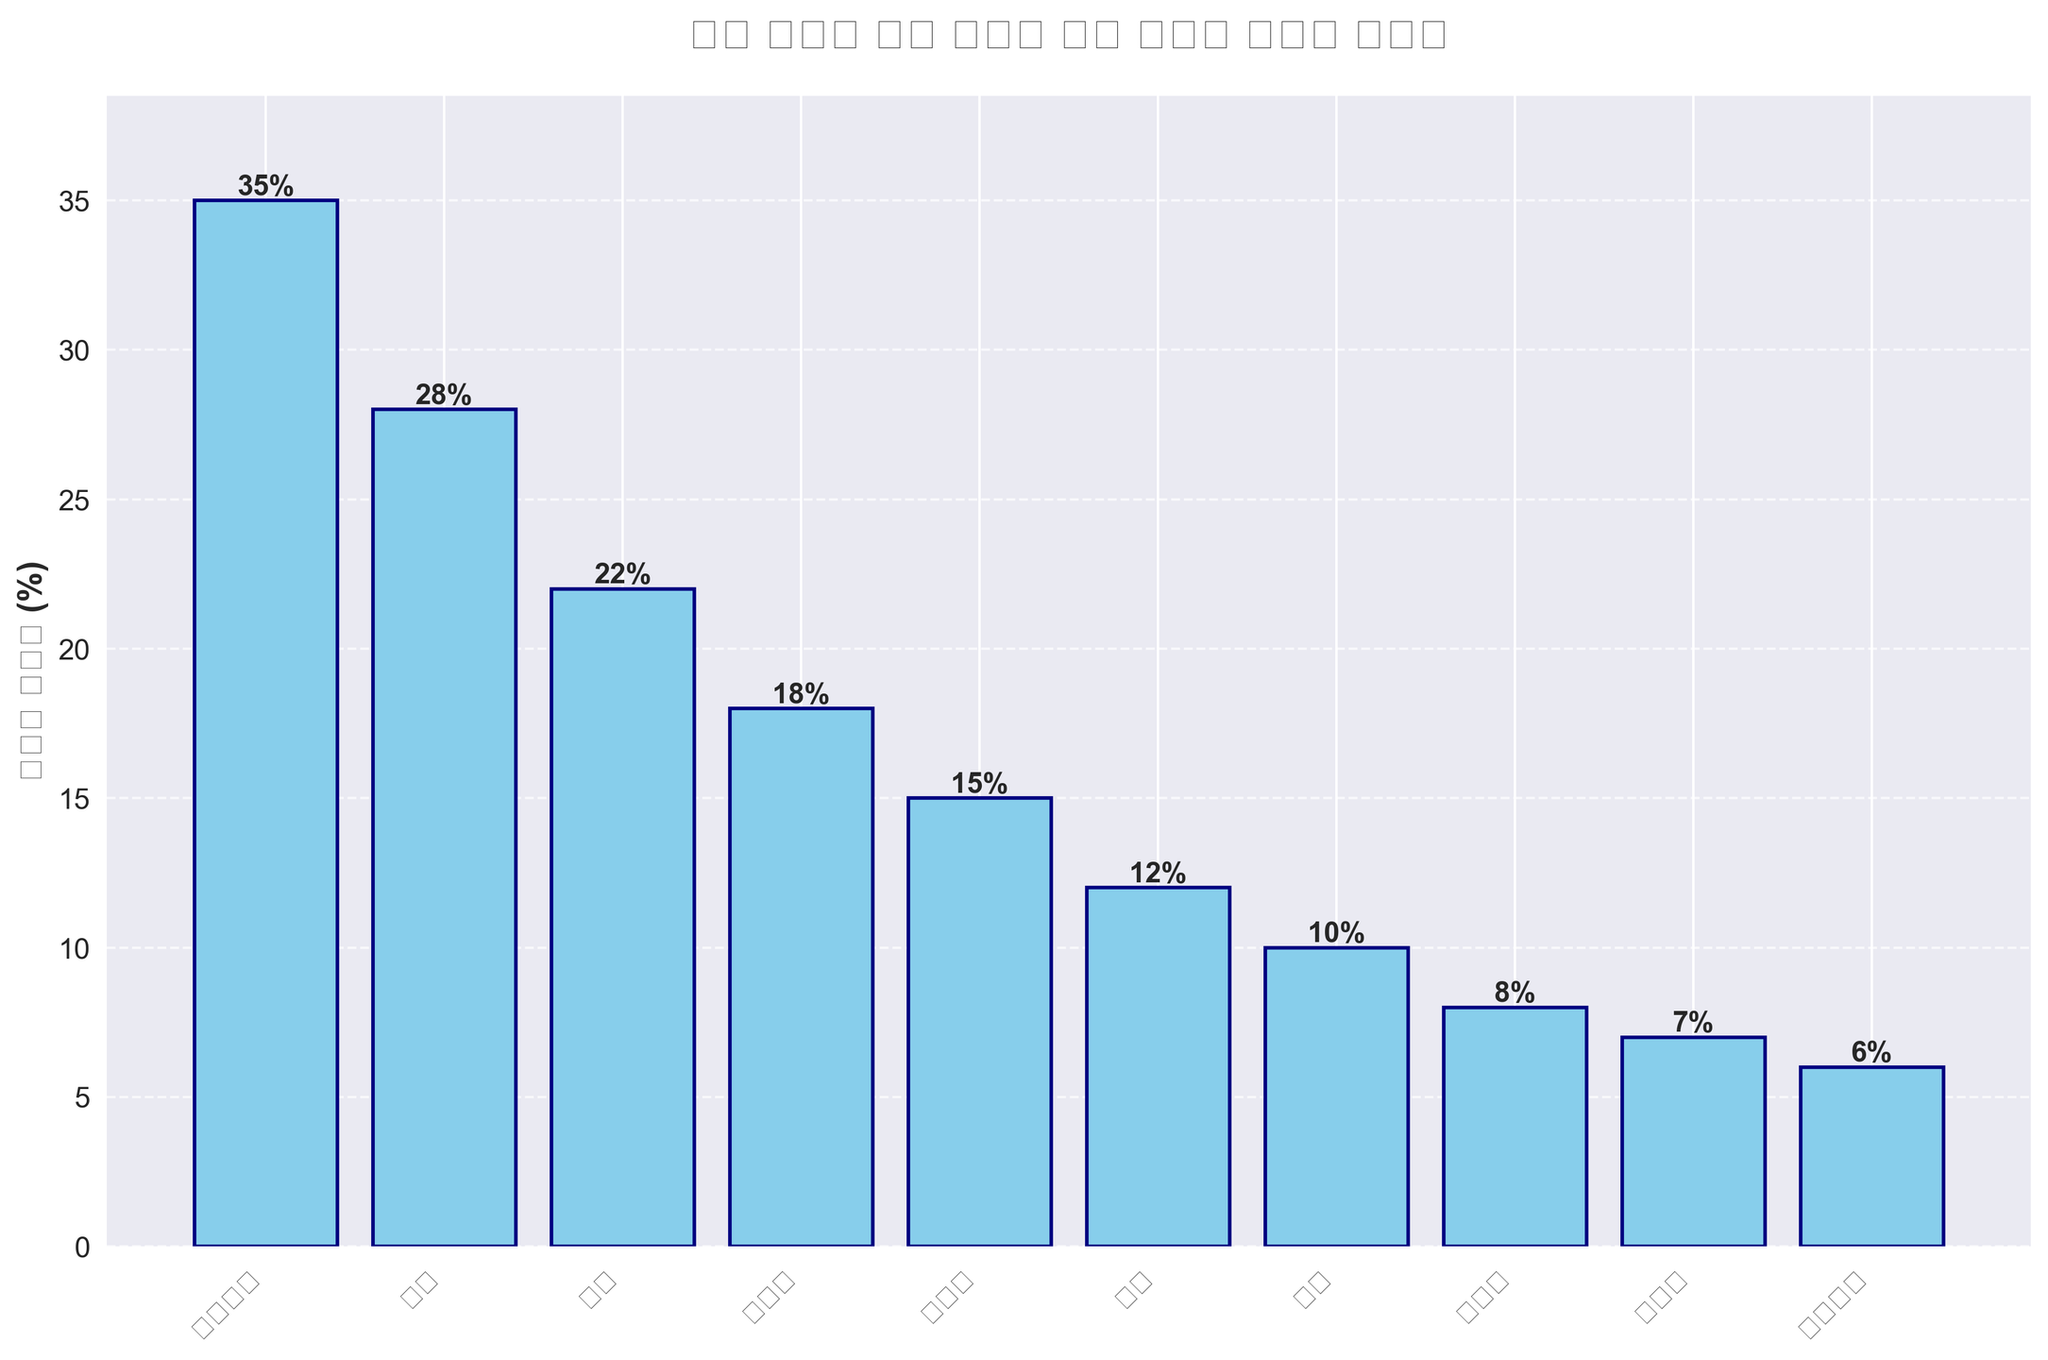어떤 나라가 가장 높은 관광객 증가율을 기록했나요? 그래프에서 가장 높은 막대를 찾아보세요. 대한민국 막대가 가장 높은데, 증가율이 35%입니다.
Answer: 대한민국 프랑스와 독일의 관광객 증가율 차이는 몇 퍼센트인가요? 프랑스의 관광객 증가율은 15%이고, 독일의 관광객 증가율은 12%입니다. 15% - 12% = 3%입니다.
Answer: 3% 가장 낮은 관광객 증가율을 기록한 두 나라는 어디인가요? 두 번째로 낮은 막대와 가장 낮은 막대를 찾아보세요. 스페인(7%)과 이탈리아(6%)가 가장 낮은 관광객 증가율을 기록했습니다.
Answer: 스페인과 이탈리아 중국, 브라질, 프랑스의 평균 관광객 증가율은 얼마인가요? 세 나라의 관광객 증가율을 더하고 나누어 평균을 구합니다: (22% + 18% + 15%) / 3 = 55% / 3 = 약 18.33%입니다.
Answer: 약 18.33% 호주와 캐나다 중 어느 나라의 관광객 증가율이 더 높습니까? 호주의 증가율은 10%이고, 캐나다의 증가율은 8%입니다. 10%가 더 높습니다.
Answer: 호주 몇 개 나라의 관광객 증가율이 두 자릿수인가요? 값이 10% 이상인 막대의 개수를 세어보면, 대한민국, 일본, 중국, 브라질, 프랑스, 독일, 호주까지 총 7개 나라입니다.
Answer: 7개 나라 관광객 증가율이 25% 이상인 나라들은 어디인가요? 증가율이 25% 이상인 막대를 찾아보면, 대한민국(35%), 일본(28%)이 해당됩니다.
Answer: 대한민국과 일본 일본의 관광객 증가율은 몇 퍼센트인가요? 일본 막대 위의 라벨을 확인하면, 28%임을 알 수 있습니다.
Answer: 28% 대한민국과 중국의 관광객 증가율 합계는 얼마인가요? 두 나라의 증가율을 더합니다: 35% + 22% = 57%입니다.
Answer: 57% 스페인보다 관광객 증가율이 낮은 나라는 몇 곳인가요? 스페인의 관광객 증가율은 7%입니다. 이보다 낮은 나라는 이탈리아(6%) 하나뿐입니다.
Answer: 1곳 